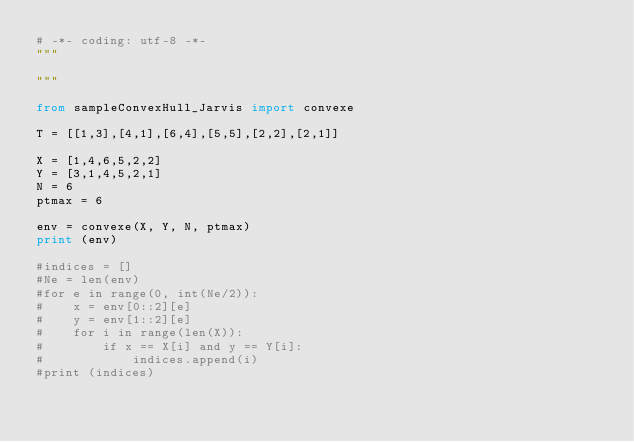<code> <loc_0><loc_0><loc_500><loc_500><_Python_># -*- coding: utf-8 -*-
"""

"""

from sampleConvexHull_Jarvis import convexe

T = [[1,3],[4,1],[6,4],[5,5],[2,2],[2,1]]

X = [1,4,6,5,2,2]
Y = [3,1,4,5,2,1]
N = 6
ptmax = 6

env = convexe(X, Y, N, ptmax)
print (env)

#indices = []
#Ne = len(env)
#for e in range(0, int(Ne/2)):
#    x = env[0::2][e]
#    y = env[1::2][e]
#    for i in range(len(X)):
#        if x == X[i] and y == Y[i]:
#            indices.append(i)
#print (indices)</code> 